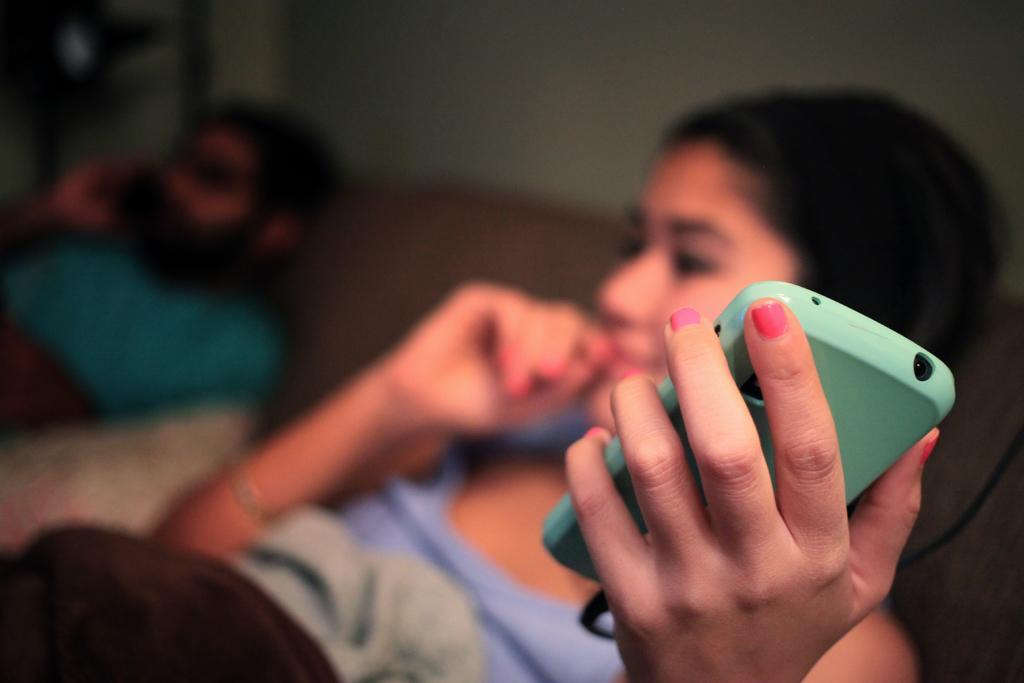Describe this image in one or two sentences. In this image i can see a woman laying on the bed and holding a mobile in her hand, she is wearing a purple and weaning black color dress at left there is other man laying and wearing a green shirt at the background i can see a wall. 